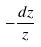Convert formula to latex. <formula><loc_0><loc_0><loc_500><loc_500>- \frac { d z } { z }</formula> 